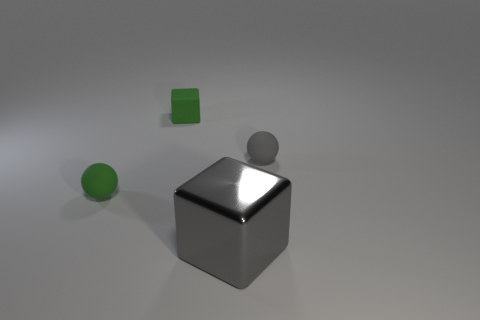Are there any other things that are the same material as the large thing?
Your response must be concise. No. What number of green objects are either tiny rubber objects or big blocks?
Your response must be concise. 2. What shape is the thing that is both behind the big gray cube and to the right of the tiny green cube?
Your response must be concise. Sphere. There is another ball that is the same size as the green rubber sphere; what is its color?
Offer a very short reply. Gray. There is a gray object behind the tiny green rubber sphere; is its size the same as the rubber block that is on the left side of the big metallic object?
Ensure brevity in your answer.  Yes. What size is the green thing that is to the right of the tiny matte sphere in front of the tiny thing on the right side of the metal thing?
Make the answer very short. Small. What shape is the green thing that is behind the small green thing that is to the left of the tiny green block?
Make the answer very short. Cube. Do the ball behind the green ball and the small block have the same color?
Your answer should be very brief. No. What is the color of the small matte thing that is behind the tiny green matte ball and to the left of the gray shiny object?
Your response must be concise. Green. Is there a small gray ball made of the same material as the big gray block?
Ensure brevity in your answer.  No. 